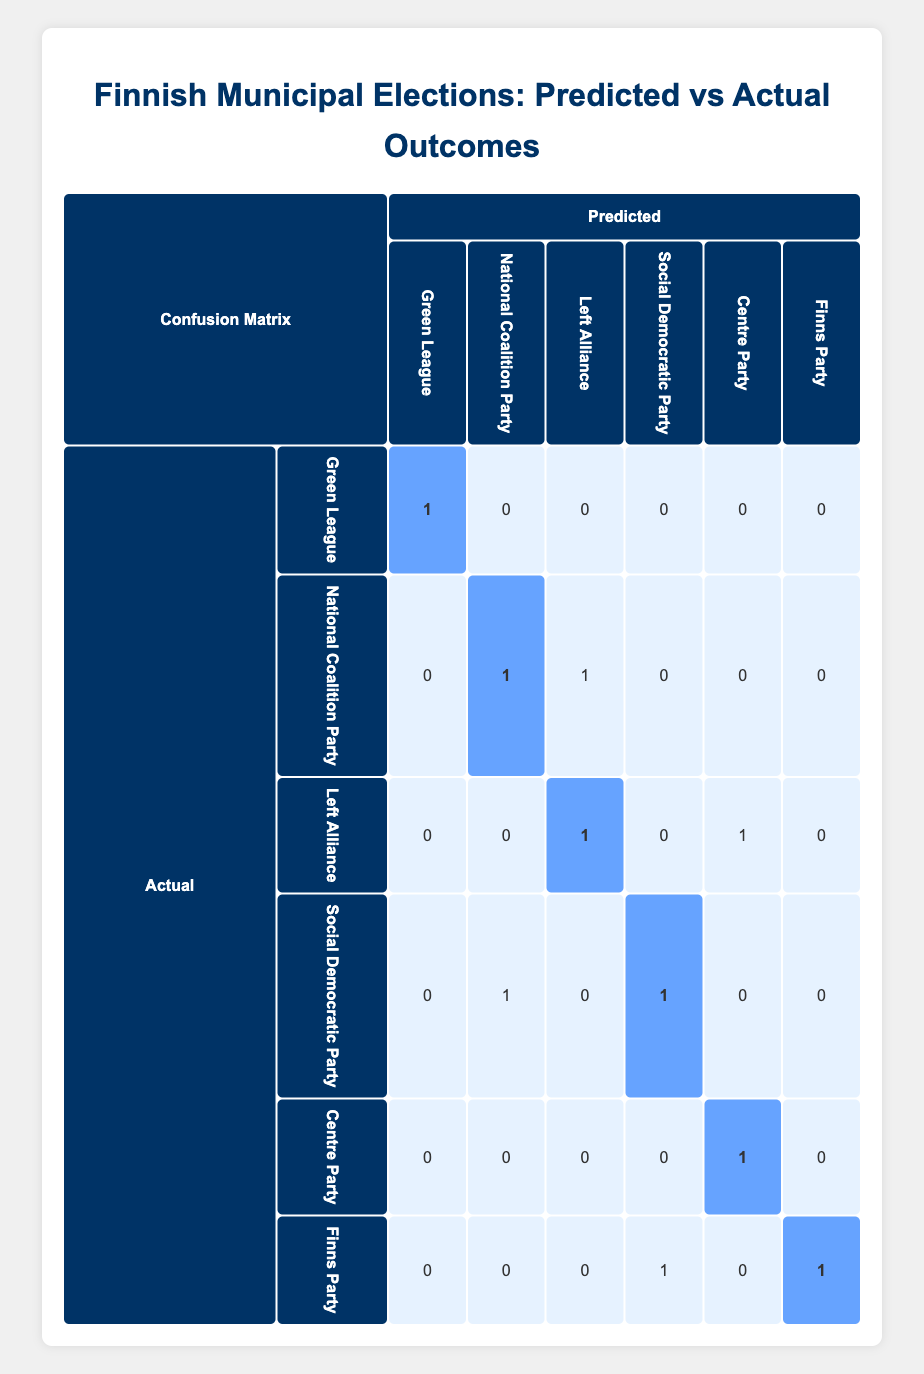What is the number of voters in the 18-24 age group who voted for the Green League? There is one entry in the table for the age group 18-24 that indicates a vote for the Green League, and it is also correctly predicted. Therefore, the number of voters in this age group who voted for the Green League is 1.
Answer: 1 Which party received the highest number of correct predictions? By examining the diagonal of the confusion matrix, we see that the Centre Party and the Finns Party both have 1 correct prediction, while the Left Alliance has 1 correct prediction as well. The highest number of correct predictions is 1, since no party has more than that in the matrix.
Answer: 1 How many total incorrect predictions did the National Coalition Party receive? The National Coalition Party is predicted correctly once. However, there are two instances where the prediction does not match the actual vote: one for the Left Alliance and one for the Social Democratic Party. Thus, total incorrect predictions sum up to 2.
Answer: 2 Is it true that the Social Democratic Party received more incorrect predictions than the Centre Party? By analyzing the predictions, the Social Democratic Party had 1 correct prediction and 1 incorrect prediction (predicted as National Coalition Party), while the Centre Party had 1 correct and 0 incorrect predictions. Therefore, the Social Democratic Party does indeed have more incorrect predictions.
Answer: Yes What is the overall accuracy of the predicted votes? To calculate accuracy, we need to look at the total number of correct predictions (5) and divide it by the total number of votes (10). Thus, accuracy = (5 correct predictions) / (10 total votes) = 0.5 or 50%.
Answer: 50% What party had the highest number of voters but was incorrectly predicted? The Left Alliance had 1 actual vote but was incorrectly predicted as the Left Alliance itself (correct) and also had an actual vote where it was incorrectly predicted as the Social Democratic Party (1) as noted in the matrix.
Answer: Left Alliance 